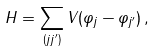Convert formula to latex. <formula><loc_0><loc_0><loc_500><loc_500>H = \sum _ { ( { j j ^ { \prime } } ) } V ( \varphi _ { j } - \varphi _ { j ^ { \prime } } ) \, ,</formula> 